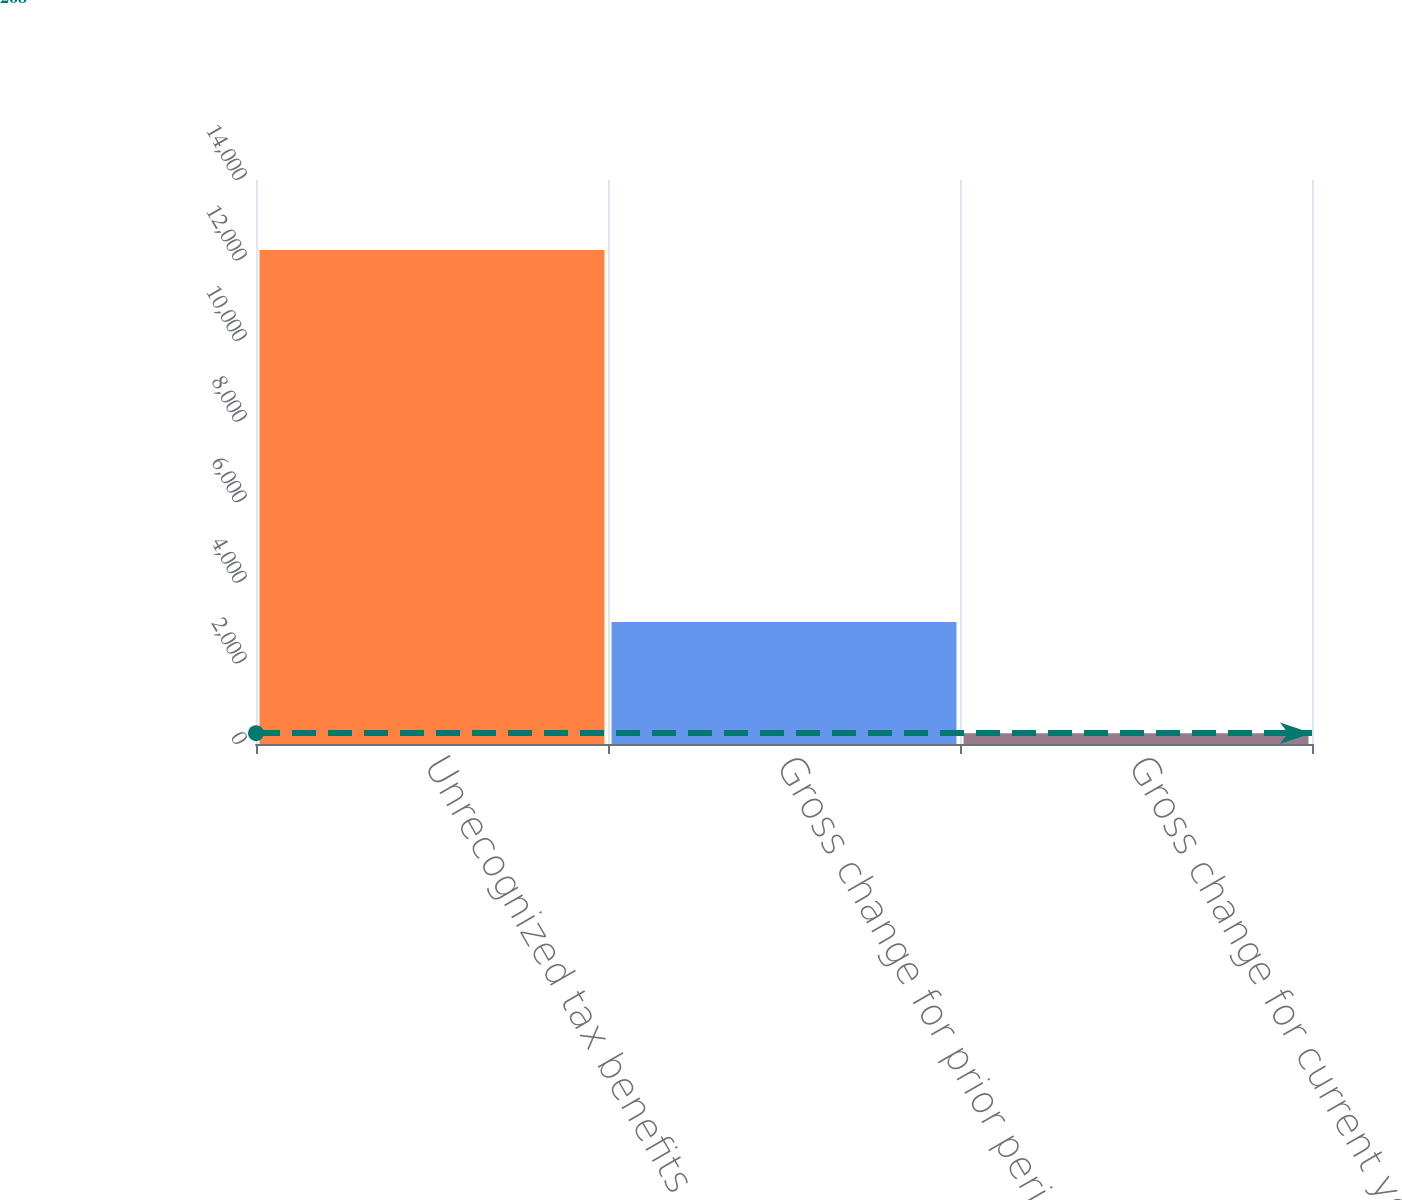<chart> <loc_0><loc_0><loc_500><loc_500><bar_chart><fcel>Unrecognized tax benefits at<fcel>Gross change for prior period<fcel>Gross change for current year<nl><fcel>12264<fcel>3029<fcel>268<nl></chart> 